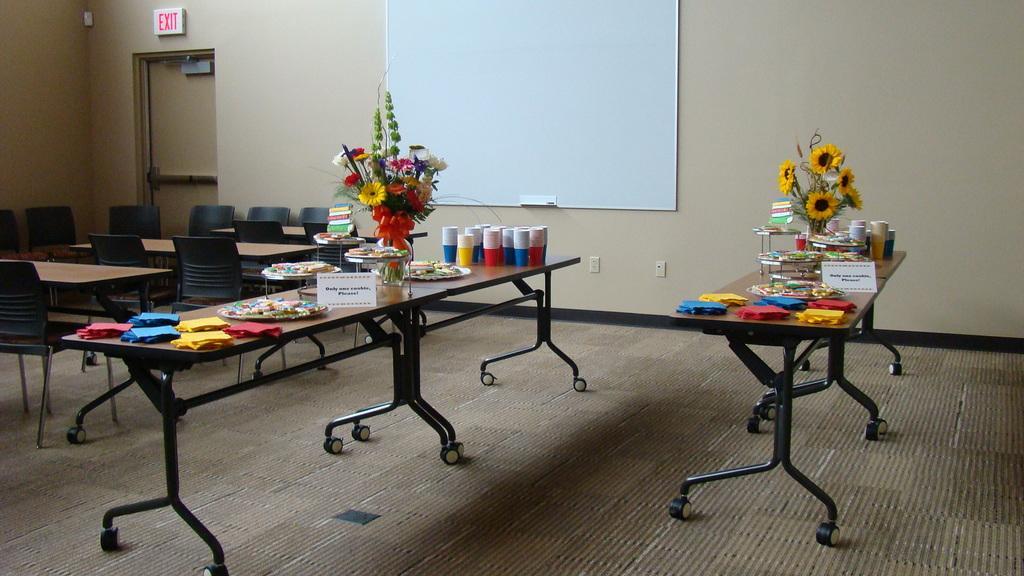In one or two sentences, can you explain what this image depicts? In this image there are two tables. On the tables there are few papers, plates, flower vase, cups and few objects on it. Left side few chairs and tables are on the floor. Background there is a board attached to the wall having a door. 